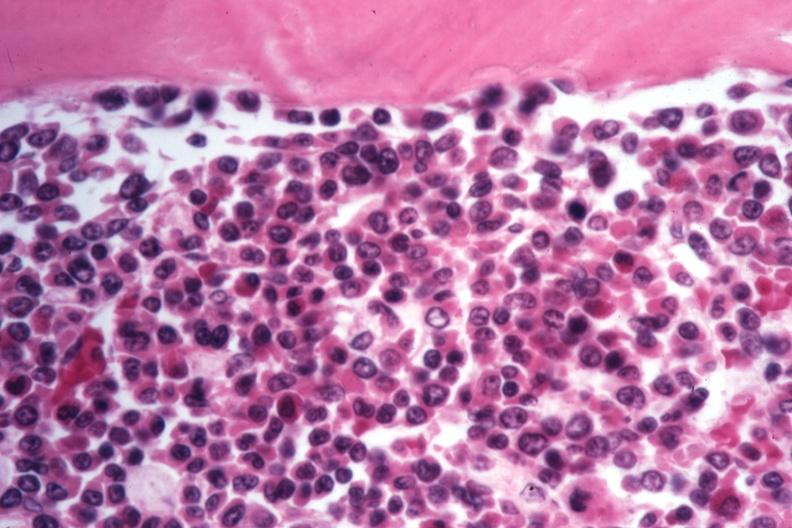s aorta present?
Answer the question using a single word or phrase. No 